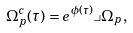Convert formula to latex. <formula><loc_0><loc_0><loc_500><loc_500>\Omega ^ { c } _ { p } ( \tau ) = e ^ { \phi ( \tau ) } \lrcorner \Omega _ { p } ,</formula> 